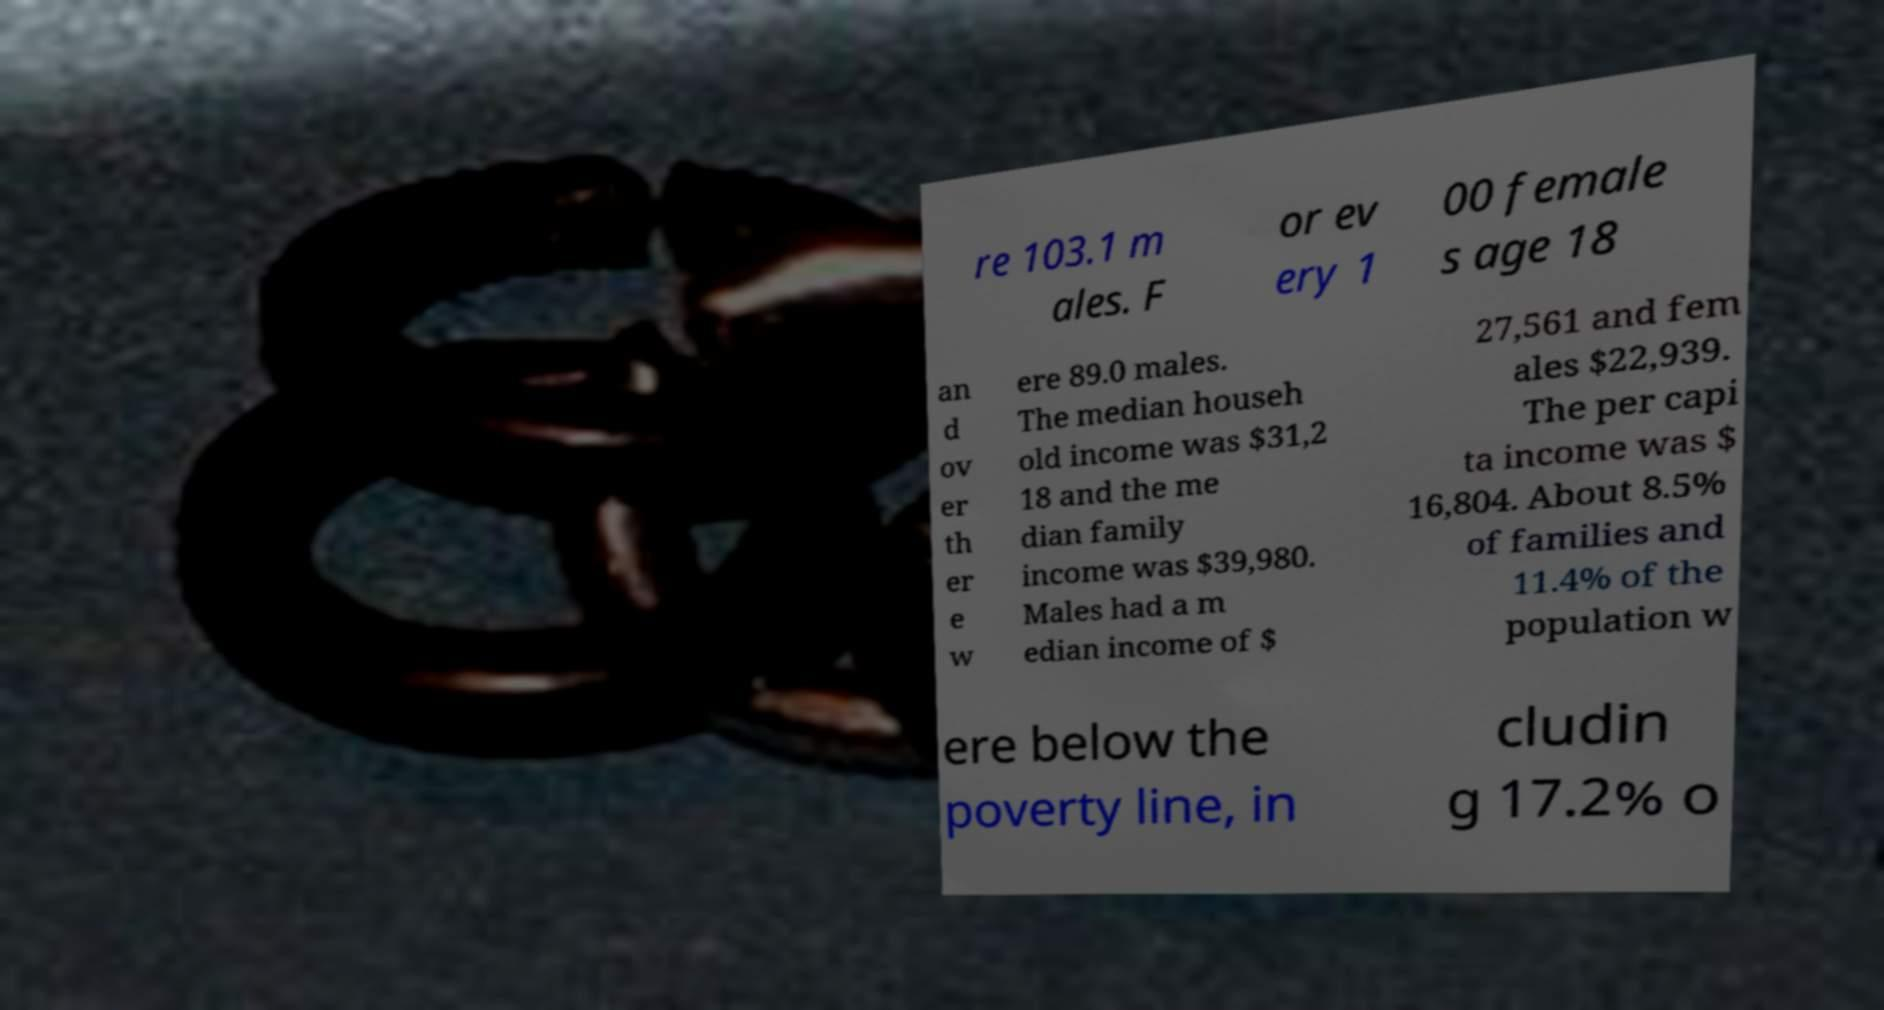I need the written content from this picture converted into text. Can you do that? re 103.1 m ales. F or ev ery 1 00 female s age 18 an d ov er th er e w ere 89.0 males. The median househ old income was $31,2 18 and the me dian family income was $39,980. Males had a m edian income of $ 27,561 and fem ales $22,939. The per capi ta income was $ 16,804. About 8.5% of families and 11.4% of the population w ere below the poverty line, in cludin g 17.2% o 